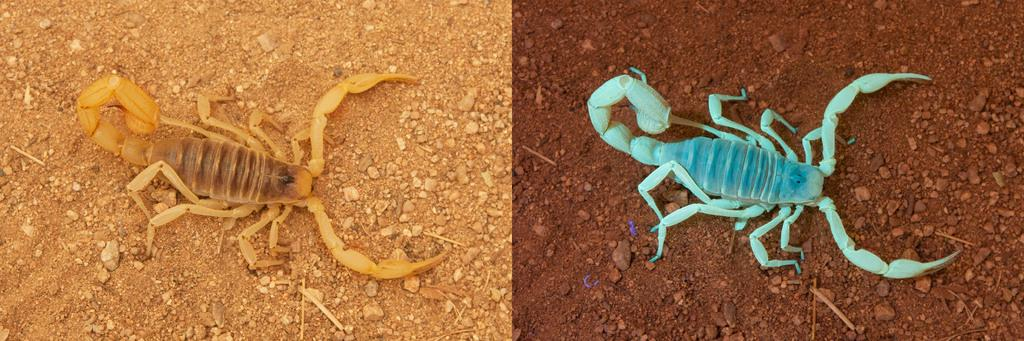How many scorpions are present in the image? There are two scorpions in the image. Where are the scorpions located? The scorpions are on the land. What type of jewel is the scorpion wearing on its claw in the image? There are no jewels present on the scorpions in the image. What power source is being used by the scorpions in the image? The scorpions do not require a power source, as they are living creatures. 